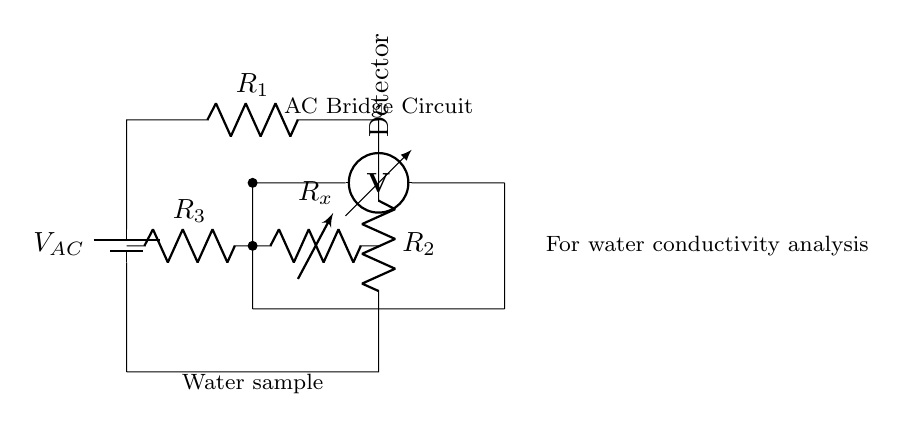What type of circuit is represented here? This circuit is an AC bridge circuit, which is specifically designed for measuring the conductivity of solutions, such as water. It features a balanced condition where the AC voltage can be detected through the use of resistive components.
Answer: AC bridge What is the role of R_x in the circuit? R_x is a variable resistor in the circuit that allows the user to adjust resistance in order to balance the bridge. This adjustment helps in determining the water conductivity by finding the resistance that results in zero voltage on the detector.
Answer: Variable resistor What does the voltmeter measure in this circuit? The voltmeter, labeled as the detector, measures the voltage difference between two points in the circuit. Its purpose is to indicate if the bridge is balanced, which occurs when the voltage read is zero.
Answer: Voltage difference What component is providing the input voltage? The battery labeled as V_AC in the diagram provides the alternating current input voltage necessary for the operation of the bridge circuit. It allows for a dynamic measurement of the water's electrical properties.
Answer: Battery How many resistors are involved in the bridge circuit? There are three resistors (R1, R2, R3) in the circuit along with the variable resistor (R_x), totaling four resistive components used for balancing the bridge.
Answer: Four What is the significance of balancing the bridge? Balancing the bridge is crucial for accurate measurements; it indicates that the ratios of the resistors are equal, allowing for the precise calculation of R_x needed for determining conductivity in the water sample.
Answer: Accurate measurements What physical property is being analyzed through this circuit? The circuit is analyzing the conductivity of water, which is a measure of how well it can conduct electricity. This property is dependent on the ions present in the water.
Answer: Conductivity 